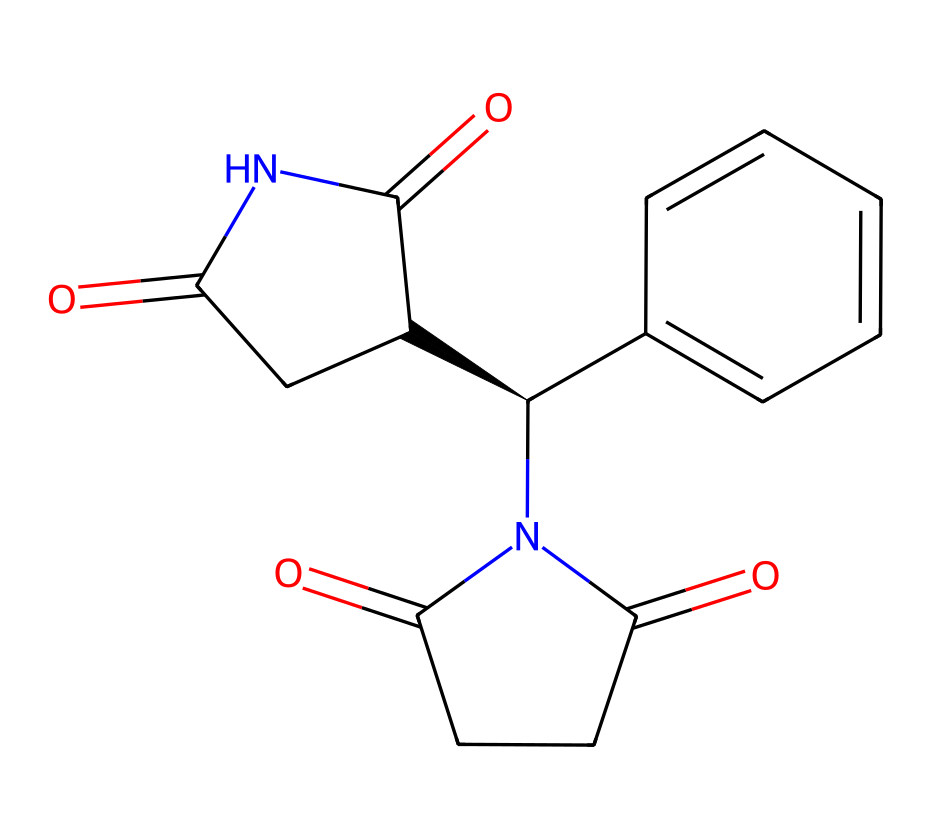How many chiral centers are present in this compound? Analyzing the structure, there is one chiral center indicated by the symbol '@' in the SMILES notation, specifically at the carbon attached to the nitrogen and adjacent to two different groups.
Answer: one chiral center What is the major functional group in thalidomide? The major functional group in the chemical structure is the amide group, which is characterized by the presence of a carbonyl (C=O) directly attached to a nitrogen (N).
Answer: amide What effect does the (R) enantiomer of thalidomide have? The (R) enantiomer of thalidomide is known to cause anti-nausea effects and is often used therapeutically.
Answer: anti-nausea What is the molecular formula for thalidomide based on its structure? By counting the various atoms in the structure provided, the molecular formula is determined to be C13H10N2O4.
Answer: C13H10N2O4 Which enantiomer of thalidomide is teratogenic? The (S) enantiomer of thalidomide is responsible for teratogenic effects, leading to severe birth defects.
Answer: (S) enantiomer 